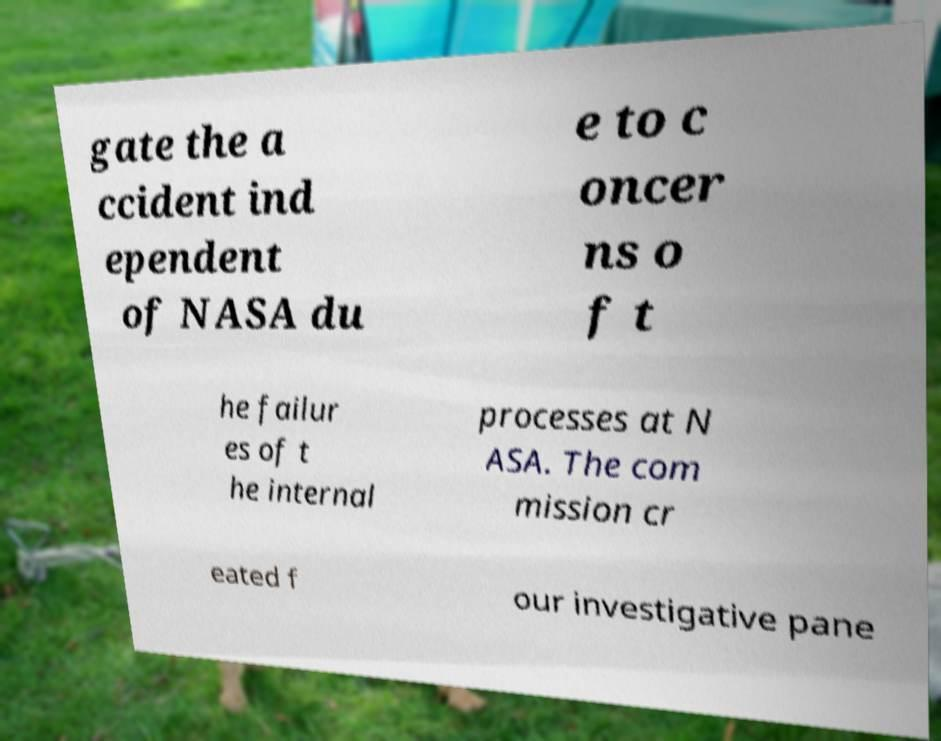For documentation purposes, I need the text within this image transcribed. Could you provide that? gate the a ccident ind ependent of NASA du e to c oncer ns o f t he failur es of t he internal processes at N ASA. The com mission cr eated f our investigative pane 